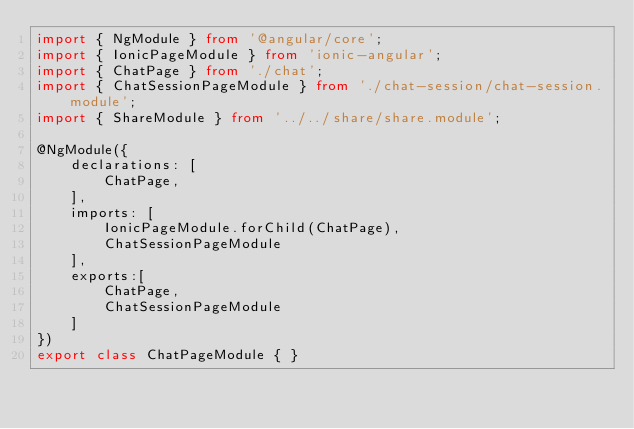Convert code to text. <code><loc_0><loc_0><loc_500><loc_500><_TypeScript_>import { NgModule } from '@angular/core';
import { IonicPageModule } from 'ionic-angular';
import { ChatPage } from './chat';
import { ChatSessionPageModule } from './chat-session/chat-session.module';
import { ShareModule } from '../../share/share.module';

@NgModule({
    declarations: [
        ChatPage,
    ],
    imports: [
        IonicPageModule.forChild(ChatPage),
        ChatSessionPageModule
    ],
    exports:[
        ChatPage,
        ChatSessionPageModule
    ]
})
export class ChatPageModule { }
</code> 